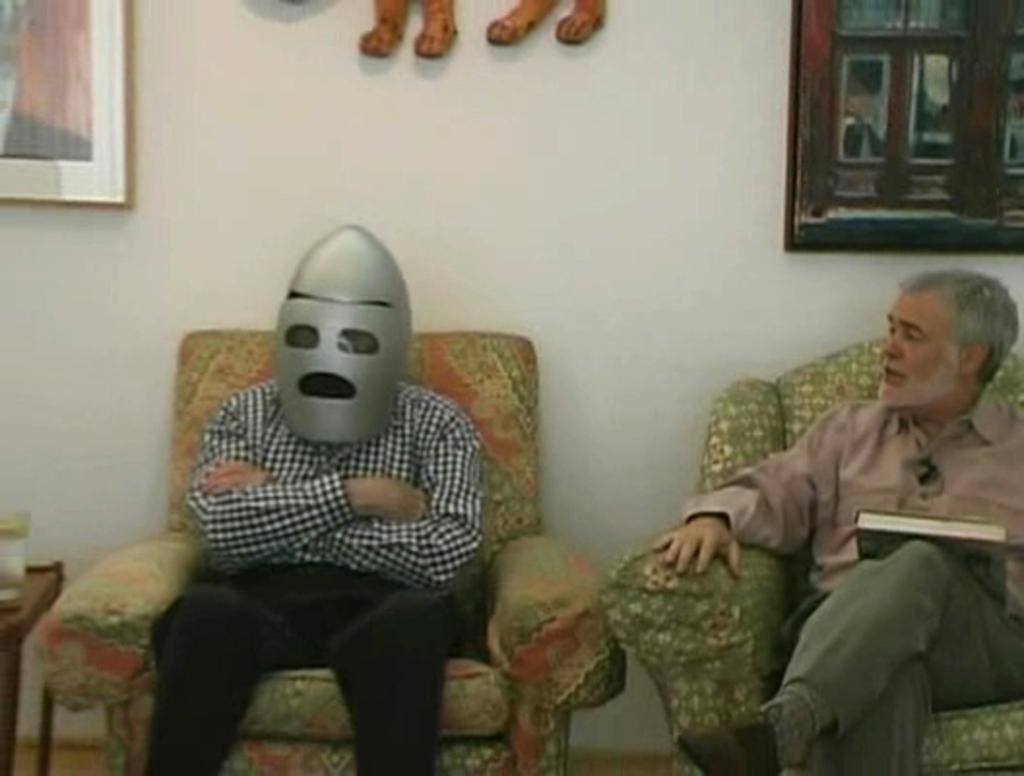Describe this image in one or two sentences. There are two men sitting in the sofas. One of the guy is wearing a mask covering his face. Other guy is looking at him. In the background there are some photo frames attached to the wall. 